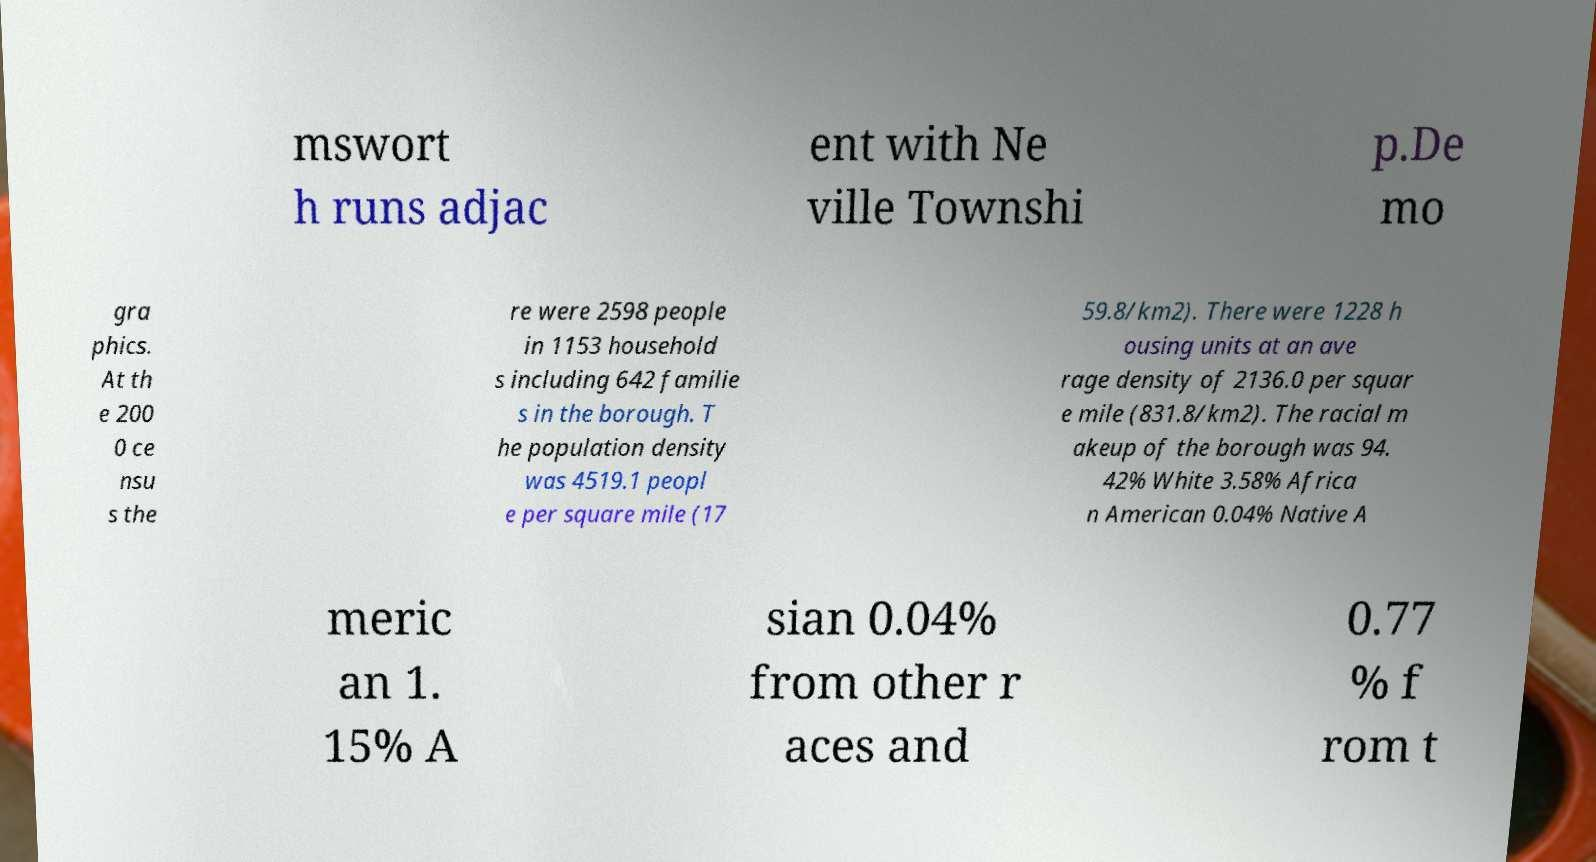There's text embedded in this image that I need extracted. Can you transcribe it verbatim? mswort h runs adjac ent with Ne ville Townshi p.De mo gra phics. At th e 200 0 ce nsu s the re were 2598 people in 1153 household s including 642 familie s in the borough. T he population density was 4519.1 peopl e per square mile (17 59.8/km2). There were 1228 h ousing units at an ave rage density of 2136.0 per squar e mile (831.8/km2). The racial m akeup of the borough was 94. 42% White 3.58% Africa n American 0.04% Native A meric an 1. 15% A sian 0.04% from other r aces and 0.77 % f rom t 